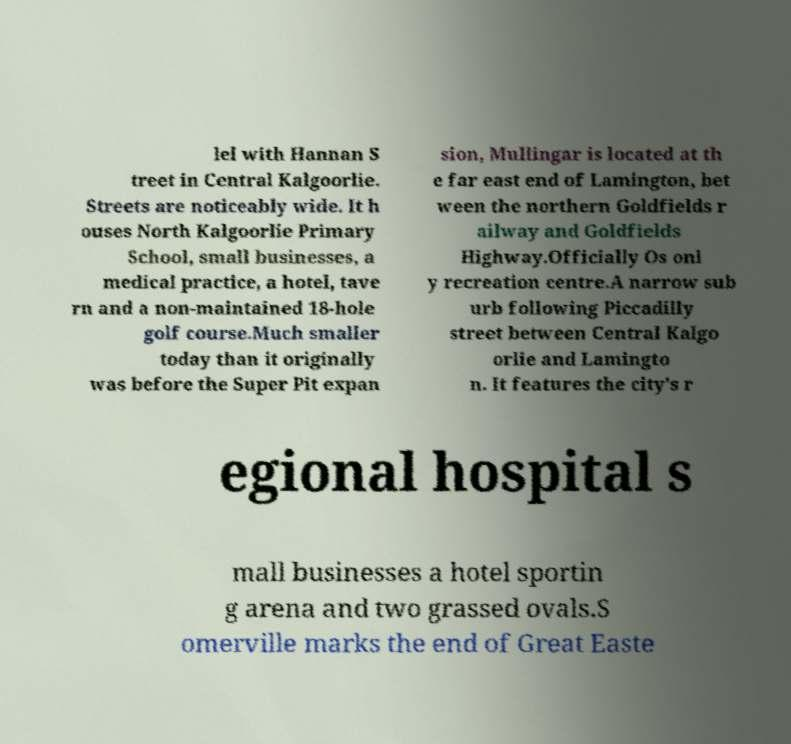Could you extract and type out the text from this image? lel with Hannan S treet in Central Kalgoorlie. Streets are noticeably wide. It h ouses North Kalgoorlie Primary School, small businesses, a medical practice, a hotel, tave rn and a non-maintained 18-hole golf course.Much smaller today than it originally was before the Super Pit expan sion, Mullingar is located at th e far east end of Lamington, bet ween the northern Goldfields r ailway and Goldfields Highway.Officially Os onl y recreation centre.A narrow sub urb following Piccadilly street between Central Kalgo orlie and Lamingto n. It features the city's r egional hospital s mall businesses a hotel sportin g arena and two grassed ovals.S omerville marks the end of Great Easte 